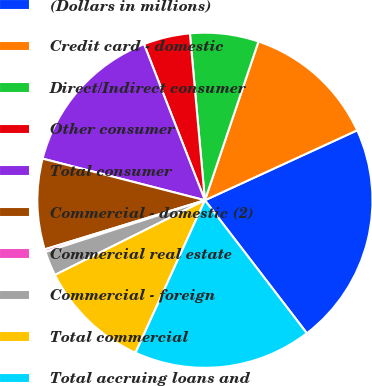Convert chart to OTSL. <chart><loc_0><loc_0><loc_500><loc_500><pie_chart><fcel>(Dollars in millions)<fcel>Credit card - domestic<fcel>Direct/Indirect consumer<fcel>Other consumer<fcel>Total consumer<fcel>Commercial - domestic (2)<fcel>Commercial real estate<fcel>Commercial - foreign<fcel>Total commercial<fcel>Total accruing loans and<nl><fcel>21.45%<fcel>12.97%<fcel>6.61%<fcel>4.49%<fcel>15.09%<fcel>8.73%<fcel>0.25%<fcel>2.37%<fcel>10.85%<fcel>17.21%<nl></chart> 